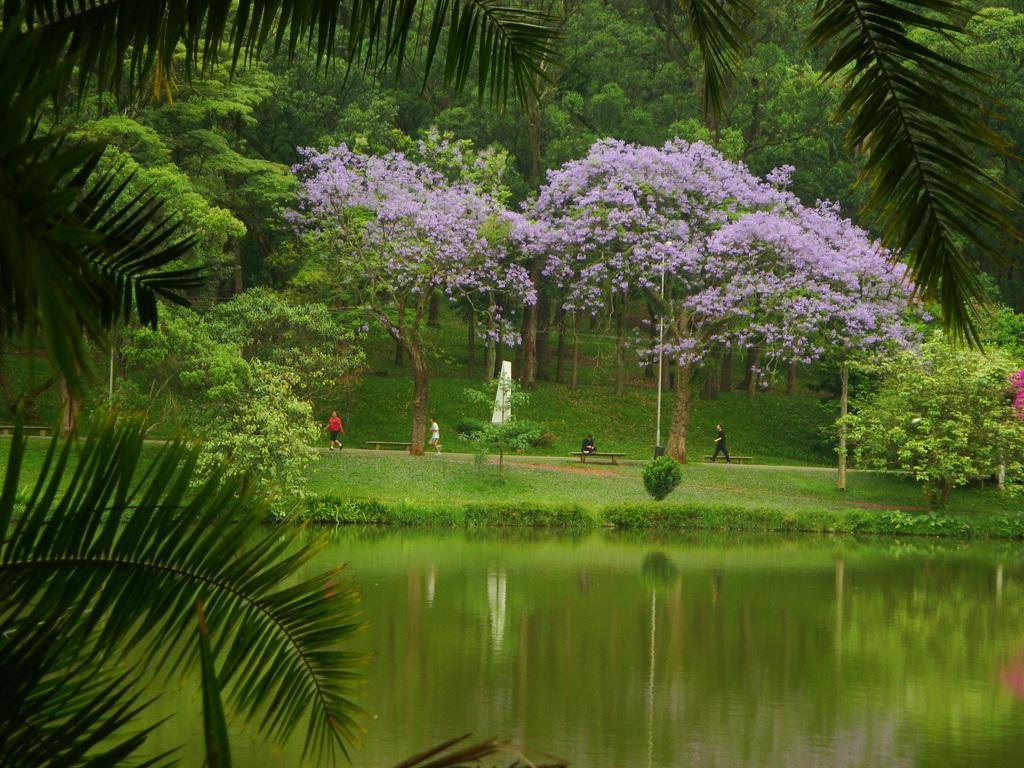What type of vegetation is present in the image? There are many trees in the image. What color are the flowers in the image? The flowers in the image are purple. What can be seen at the bottom of the image? There is water visible at the bottom of the image. How many people are in the front of the image? There are four persons in the front of the image. Can you see a gun in the image? No, there is no gun present in the image. Is the image set in space? No, the image is not set in space; it features trees, flowers, water, and people. 